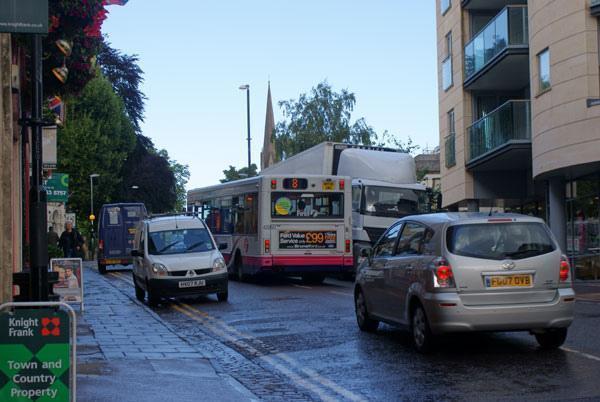How many cars are on the street?
Give a very brief answer. 2. How many cars are there?
Give a very brief answer. 2. How many trucks can be seen?
Give a very brief answer. 3. How many birds are in the air?
Give a very brief answer. 0. 